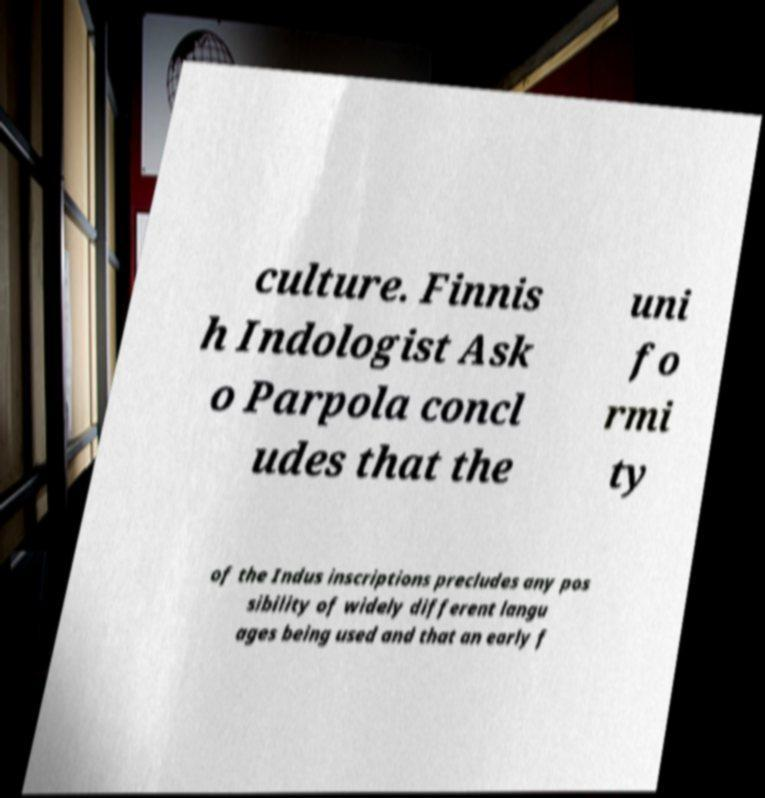Could you extract and type out the text from this image? culture. Finnis h Indologist Ask o Parpola concl udes that the uni fo rmi ty of the Indus inscriptions precludes any pos sibility of widely different langu ages being used and that an early f 